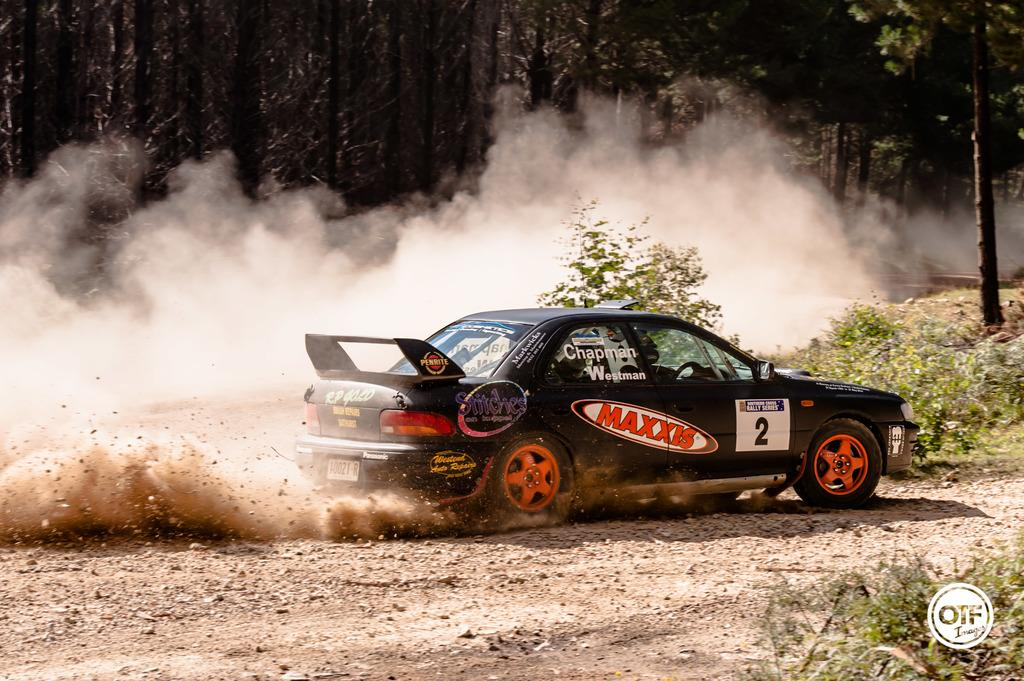What is the main subject of the image? There is a car on the road in the image. Can you describe the environment around the car? There is smoke or dust beside the car. What type of natural scenery can be seen in the image? There are trees visible in the image. What type of furniture can be seen in the image? There is no furniture present in the image; it features a car on the road with smoke or dust beside it and trees in the background. 